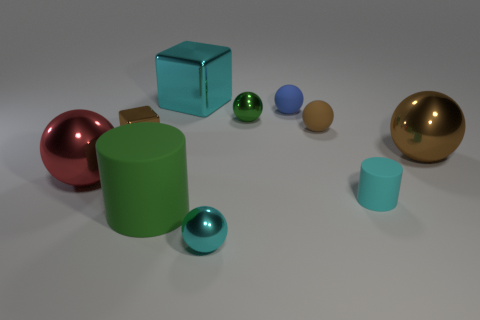What material is the green cylinder?
Provide a short and direct response. Rubber. The tiny cyan thing that is on the right side of the small green sphere behind the big red metallic thing in front of the brown rubber ball is made of what material?
Ensure brevity in your answer.  Rubber. What is the shape of the brown thing that is the same size as the green rubber thing?
Make the answer very short. Sphere. What number of objects are either small cylinders or shiny objects that are on the left side of the brown matte sphere?
Provide a succinct answer. 6. Are the large cube that is behind the green metal ball and the tiny brown thing left of the large shiny cube made of the same material?
Keep it short and to the point. Yes. There is a rubber object that is the same color as the tiny block; what is its shape?
Keep it short and to the point. Sphere. What number of brown objects are either tiny cylinders or small metal objects?
Make the answer very short. 1. What size is the brown metal block?
Offer a very short reply. Small. Are there more tiny shiny things that are in front of the small brown metallic cube than tiny blue cubes?
Your response must be concise. Yes. How many big metal balls are behind the small blue thing?
Your response must be concise. 0. 